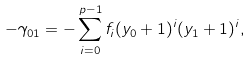Convert formula to latex. <formula><loc_0><loc_0><loc_500><loc_500>- \gamma _ { 0 1 } = - \sum _ { i = 0 } ^ { p - 1 } f _ { i } ( y _ { 0 } + 1 ) ^ { i } ( y _ { 1 } + 1 ) ^ { i } ,</formula> 